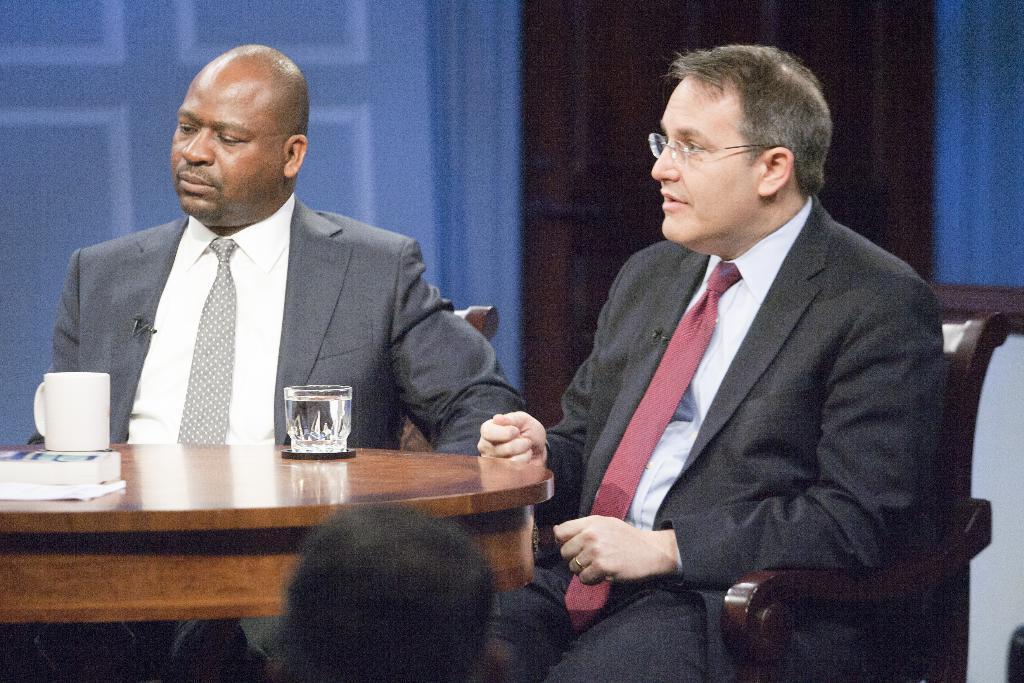Can you describe this image briefly? In this image i can see two persons who are wearing suits in front of them there is a glass and coffee cup on the table. 